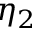Convert formula to latex. <formula><loc_0><loc_0><loc_500><loc_500>\eta _ { 2 }</formula> 